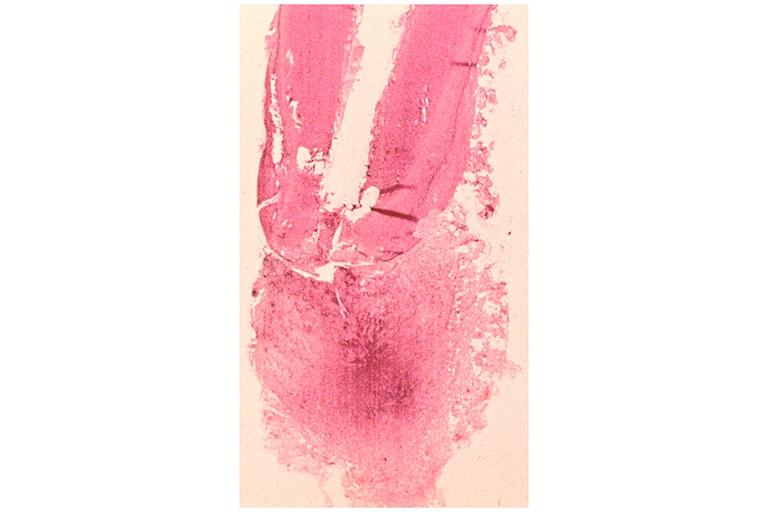where is this?
Answer the question using a single word or phrase. Oral 